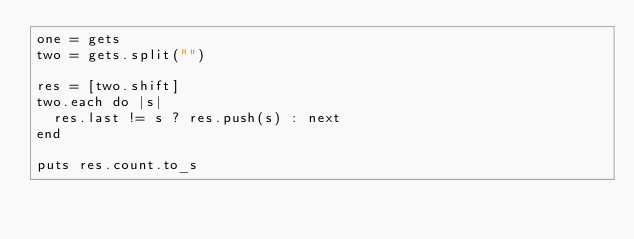Convert code to text. <code><loc_0><loc_0><loc_500><loc_500><_Ruby_>one = gets
two = gets.split("")
 
res = [two.shift]
two.each do |s|
  res.last != s ? res.push(s) : next
end
 
puts res.count.to_s</code> 